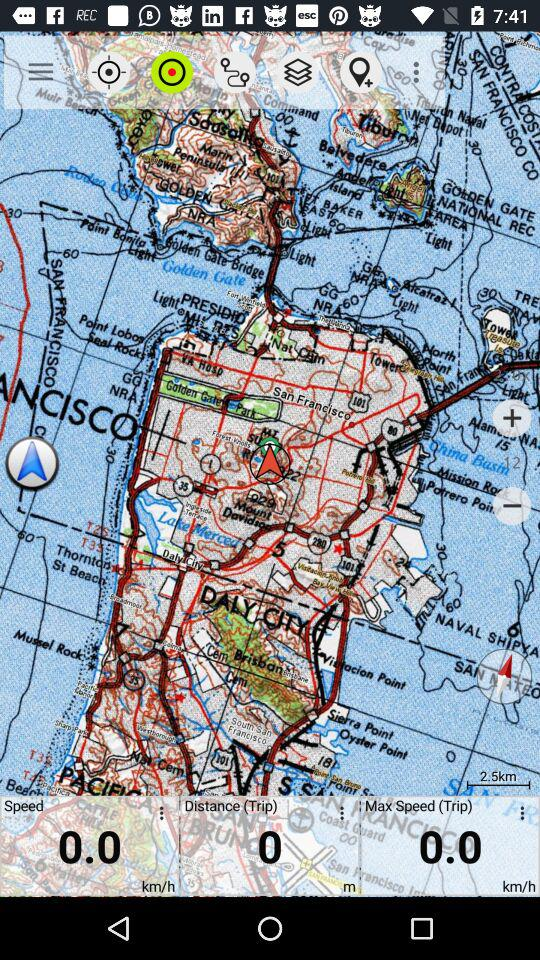What is the max. speed? The max. speed is 0 km/h. 